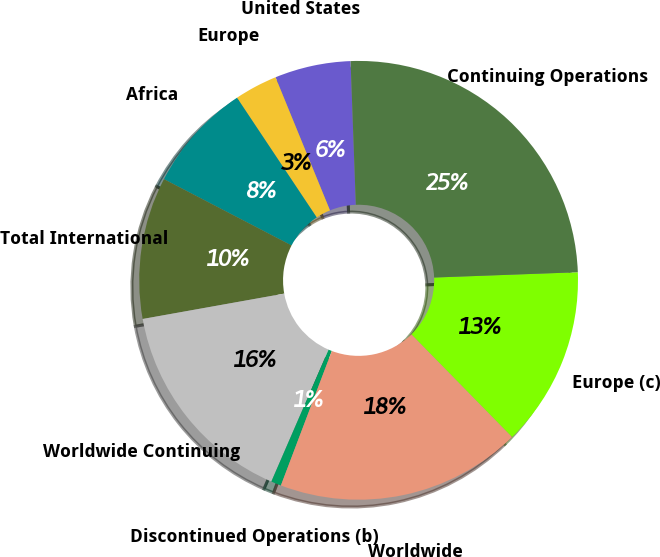Convert chart. <chart><loc_0><loc_0><loc_500><loc_500><pie_chart><fcel>United States<fcel>Europe<fcel>Africa<fcel>Total International<fcel>Worldwide Continuing<fcel>Discontinued Operations (b)<fcel>Worldwide<fcel>Europe (c)<fcel>Continuing Operations<nl><fcel>5.6%<fcel>3.17%<fcel>8.02%<fcel>10.45%<fcel>15.67%<fcel>0.75%<fcel>18.1%<fcel>13.25%<fcel>25.0%<nl></chart> 